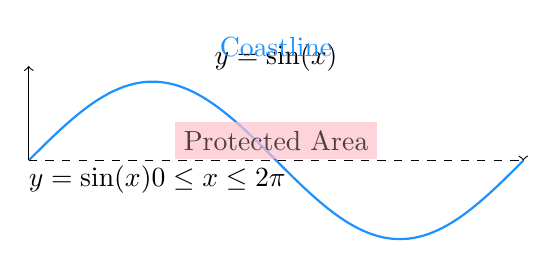Can you answer this question? Let's approach this step-by-step:

1) The area between the curve $y = \sin(x)$ and the x-axis from 0 to $2\pi$ is:

   $$A = \int_0^{2\pi} \sin(x) dx = [-\cos(x)]_0^{2\pi} = 4$$

2) We need to enclose an area of 10 square units. So, the straight line must be above the x-axis. Let's say its equation is $y = h$ where $h > 0$.

3) The area between $y = h$ and $y = \sin(x)$ from 0 to $2\pi$ should be 10:

   $$10 = 2\pi h - 4$$
   $$h = \frac{14}{2\pi} \approx 2.2284$$

4) Now, we need to minimize the perimeter. The perimeter consists of:
   - The curve length of $y = \sin(x)$ from 0 to $2\pi$
   - The straight line segment
   - Two vertical lines at $x = 0$ and $x = 2\pi$

5) The curve length is fixed. The two vertical lines have a total length of $2h$. So, we only need to minimize the length of the straight line segment.

6) The length of the straight line segment is given by:

   $$L = \sqrt{(2\pi)^2 + 0^2} = 2\pi \approx 6.2832$$

7) Therefore, the total perimeter is:

   $$P = \text{(curve length)} + 2\pi + 2h$$

   The curve length and $2\pi$ are constants, and $h$ is fixed by the area constraint. So, this straight line segment indeed minimizes the perimeter.
Answer: $2\pi \approx 6.2832$ units 